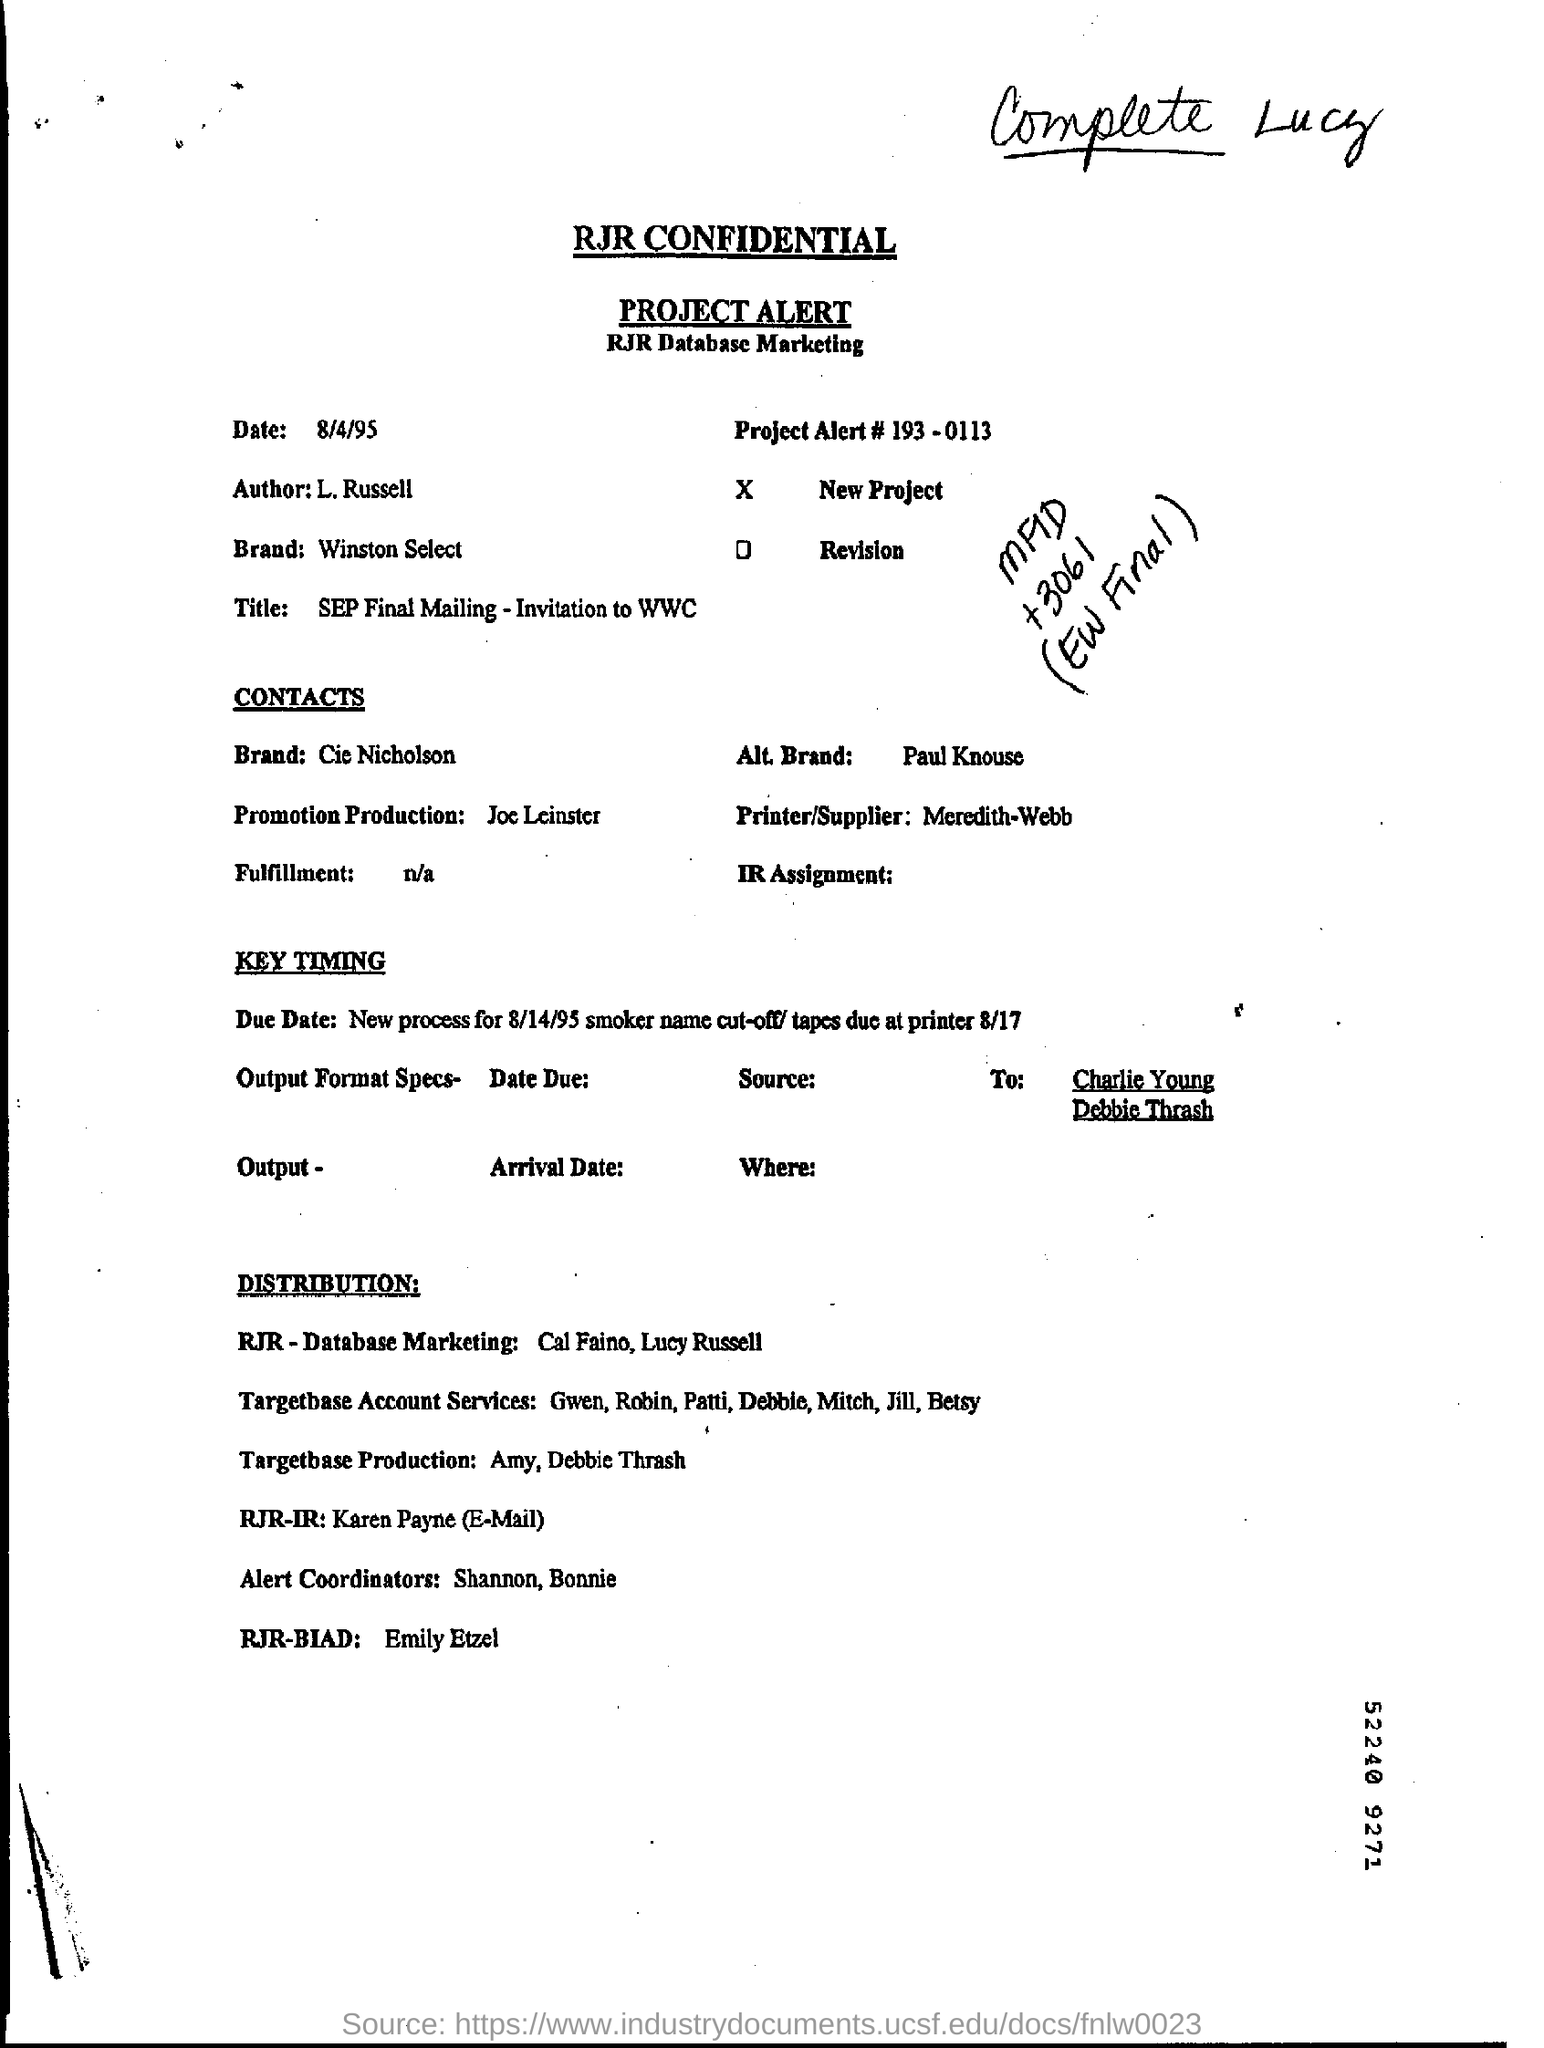What is the Author Name ?
Offer a terse response. L. Russell. What is written in the Promotion Production Field  ?
Offer a very short reply. Joe leinster. What is the date mentioned in the top of the document ?
Provide a short and direct response. 8/4/95. What is the Project Alert Number ?
Give a very brief answer. 193 - 0113. What is mentioned in the Fulfillment Field ?
Give a very brief answer. N/a. What is the Title Name ?
Give a very brief answer. SEP Final Mailing - Invitation to WWC. What is mentioned in the Alt. Brand ?
Ensure brevity in your answer.  Paul Knouse. 